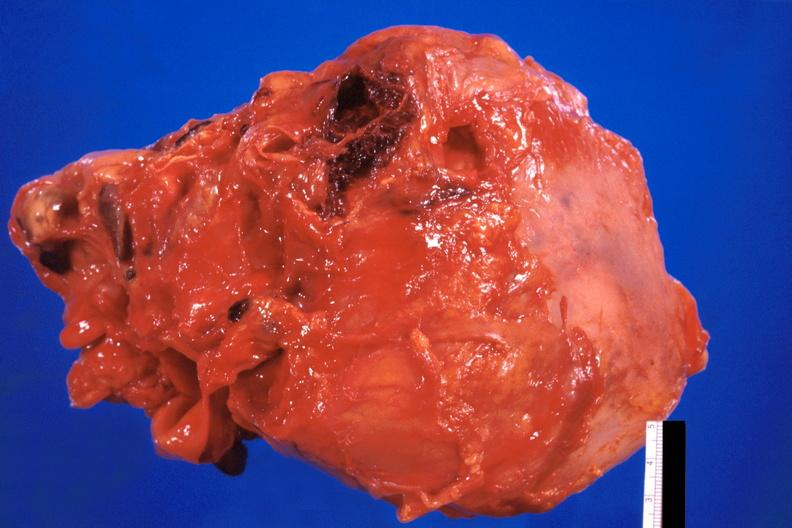s nodular tumor present?
Answer the question using a single word or phrase. No 